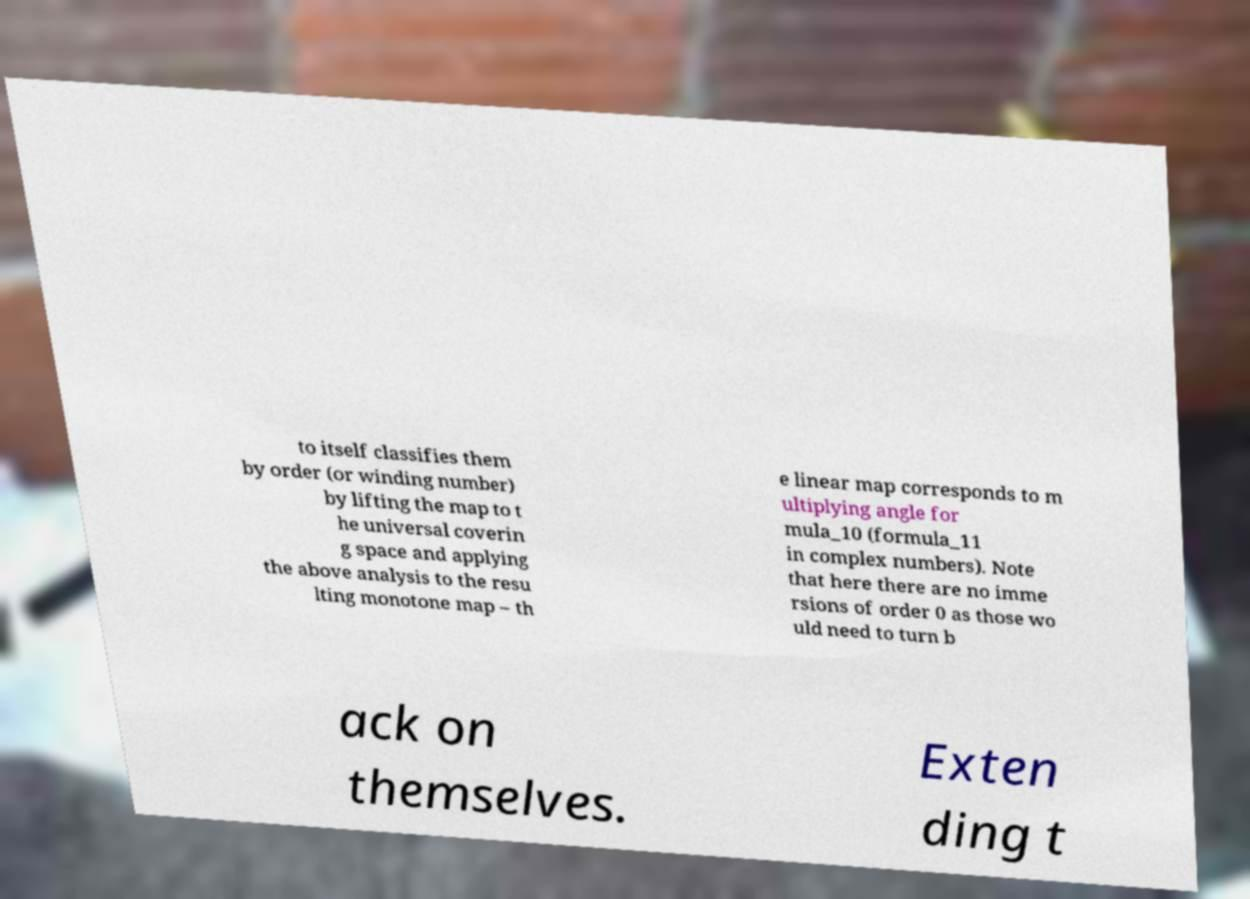Please read and relay the text visible in this image. What does it say? to itself classifies them by order (or winding number) by lifting the map to t he universal coverin g space and applying the above analysis to the resu lting monotone map – th e linear map corresponds to m ultiplying angle for mula_10 (formula_11 in complex numbers). Note that here there are no imme rsions of order 0 as those wo uld need to turn b ack on themselves. Exten ding t 